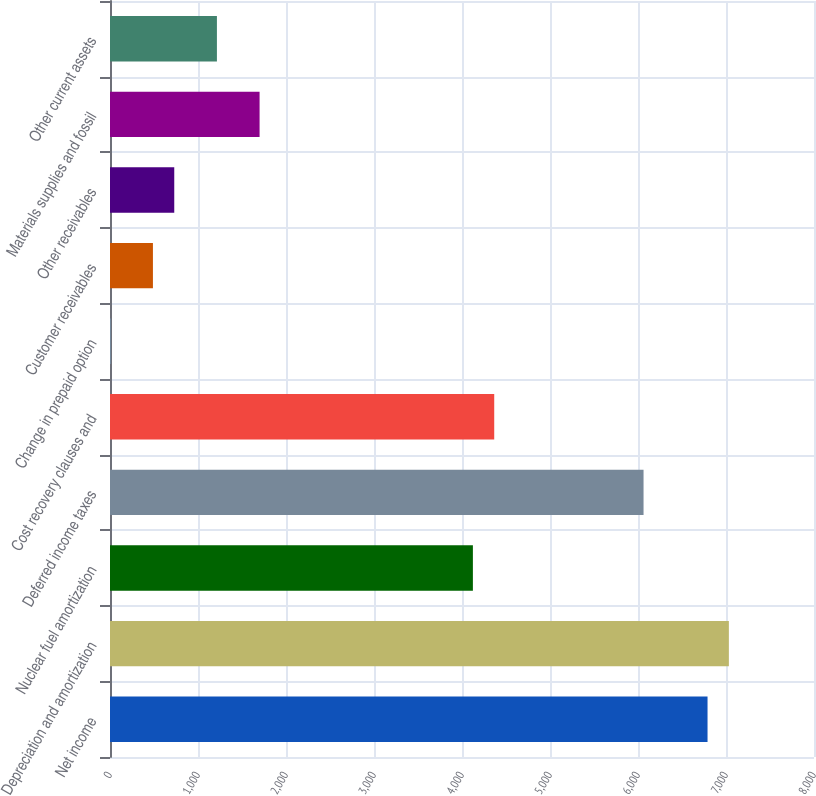<chart> <loc_0><loc_0><loc_500><loc_500><bar_chart><fcel>Net income<fcel>Depreciation and amortization<fcel>Nuclear fuel amortization<fcel>Deferred income taxes<fcel>Cost recovery clauses and<fcel>Change in prepaid option<fcel>Customer receivables<fcel>Other receivables<fcel>Materials supplies and fossil<fcel>Other current assets<nl><fcel>6790.2<fcel>7032.6<fcel>4123.8<fcel>6063<fcel>4366.2<fcel>3<fcel>487.8<fcel>730.2<fcel>1699.8<fcel>1215<nl></chart> 